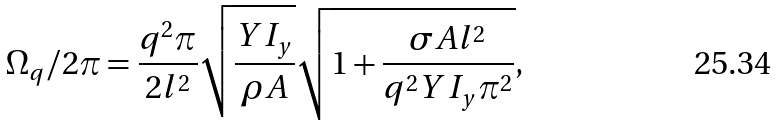Convert formula to latex. <formula><loc_0><loc_0><loc_500><loc_500>\Omega _ { q } / 2 \pi = \frac { q ^ { 2 } \pi } { 2 l ^ { 2 } } \sqrt { \frac { Y I _ { y } } { \rho A } } \sqrt { 1 + \frac { \sigma A l ^ { 2 } } { q ^ { 2 } Y I _ { y } \pi ^ { 2 } } } ,</formula> 